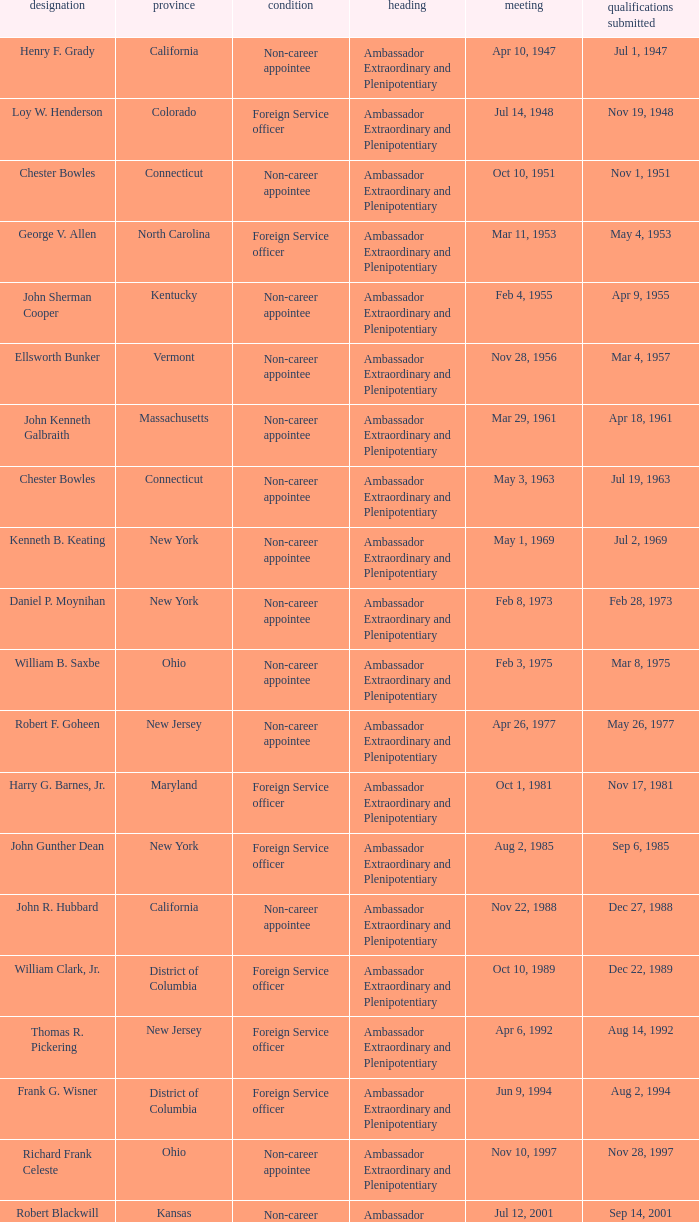What is the title for david campbell mulford? Ambassador Extraordinary and Plenipotentiary. 